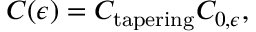<formula> <loc_0><loc_0><loc_500><loc_500>C ( \epsilon ) = C _ { t a p e r i n g } C _ { 0 , \epsilon } ,</formula> 